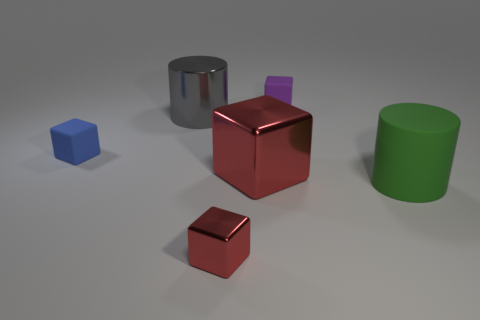What shape is the thing that is the same color as the large shiny block?
Make the answer very short. Cube. What color is the big metallic thing that is the same shape as the tiny shiny thing?
Your answer should be very brief. Red. What shape is the tiny thing that is both on the left side of the small purple matte object and behind the tiny shiny thing?
Ensure brevity in your answer.  Cube. Do the cylinder that is behind the big red metal object and the purple block have the same material?
Offer a terse response. No. How many objects are red metal things or matte cubes behind the blue rubber thing?
Make the answer very short. 3. There is a large cylinder that is the same material as the purple object; what is its color?
Your response must be concise. Green. How many other cubes have the same material as the purple block?
Offer a very short reply. 1. How many small blue balls are there?
Give a very brief answer. 0. There is a big cylinder to the left of the purple block; does it have the same color as the big rubber cylinder that is in front of the large red metallic object?
Provide a short and direct response. No. How many purple blocks are in front of the blue object?
Offer a terse response. 0. 